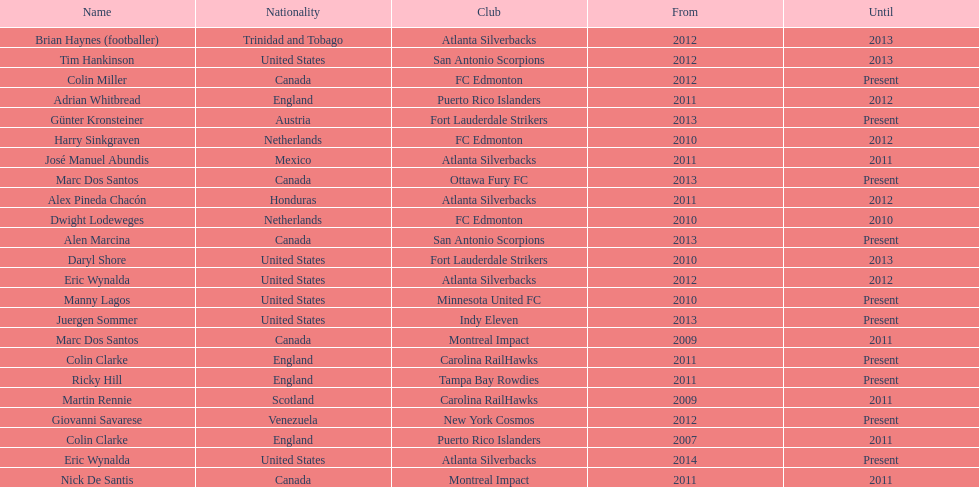Write the full table. {'header': ['Name', 'Nationality', 'Club', 'From', 'Until'], 'rows': [['Brian Haynes (footballer)', 'Trinidad and Tobago', 'Atlanta Silverbacks', '2012', '2013'], ['Tim Hankinson', 'United States', 'San Antonio Scorpions', '2012', '2013'], ['Colin Miller', 'Canada', 'FC Edmonton', '2012', 'Present'], ['Adrian Whitbread', 'England', 'Puerto Rico Islanders', '2011', '2012'], ['Günter Kronsteiner', 'Austria', 'Fort Lauderdale Strikers', '2013', 'Present'], ['Harry Sinkgraven', 'Netherlands', 'FC Edmonton', '2010', '2012'], ['José Manuel Abundis', 'Mexico', 'Atlanta Silverbacks', '2011', '2011'], ['Marc Dos Santos', 'Canada', 'Ottawa Fury FC', '2013', 'Present'], ['Alex Pineda Chacón', 'Honduras', 'Atlanta Silverbacks', '2011', '2012'], ['Dwight Lodeweges', 'Netherlands', 'FC Edmonton', '2010', '2010'], ['Alen Marcina', 'Canada', 'San Antonio Scorpions', '2013', 'Present'], ['Daryl Shore', 'United States', 'Fort Lauderdale Strikers', '2010', '2013'], ['Eric Wynalda', 'United States', 'Atlanta Silverbacks', '2012', '2012'], ['Manny Lagos', 'United States', 'Minnesota United FC', '2010', 'Present'], ['Juergen Sommer', 'United States', 'Indy Eleven', '2013', 'Present'], ['Marc Dos Santos', 'Canada', 'Montreal Impact', '2009', '2011'], ['Colin Clarke', 'England', 'Carolina RailHawks', '2011', 'Present'], ['Ricky Hill', 'England', 'Tampa Bay Rowdies', '2011', 'Present'], ['Martin Rennie', 'Scotland', 'Carolina RailHawks', '2009', '2011'], ['Giovanni Savarese', 'Venezuela', 'New York Cosmos', '2012', 'Present'], ['Colin Clarke', 'England', 'Puerto Rico Islanders', '2007', '2011'], ['Eric Wynalda', 'United States', 'Atlanta Silverbacks', '2014', 'Present'], ['Nick De Santis', 'Canada', 'Montreal Impact', '2011', '2011']]} How long did colin clarke coach the puerto rico islanders? 4 years. 